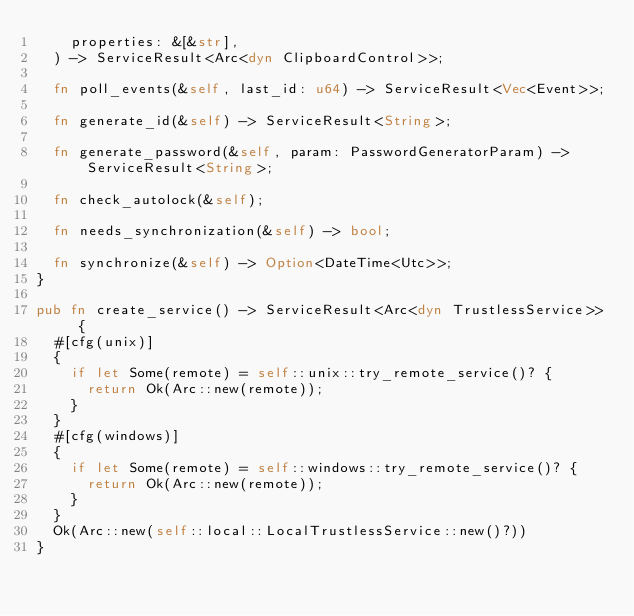<code> <loc_0><loc_0><loc_500><loc_500><_Rust_>    properties: &[&str],
  ) -> ServiceResult<Arc<dyn ClipboardControl>>;

  fn poll_events(&self, last_id: u64) -> ServiceResult<Vec<Event>>;

  fn generate_id(&self) -> ServiceResult<String>;

  fn generate_password(&self, param: PasswordGeneratorParam) -> ServiceResult<String>;

  fn check_autolock(&self);

  fn needs_synchronization(&self) -> bool;

  fn synchronize(&self) -> Option<DateTime<Utc>>;
}

pub fn create_service() -> ServiceResult<Arc<dyn TrustlessService>> {
  #[cfg(unix)]
  {
    if let Some(remote) = self::unix::try_remote_service()? {
      return Ok(Arc::new(remote));
    }
  }
  #[cfg(windows)]
  {
    if let Some(remote) = self::windows::try_remote_service()? {
      return Ok(Arc::new(remote));
    }
  }
  Ok(Arc::new(self::local::LocalTrustlessService::new()?))
}
</code> 